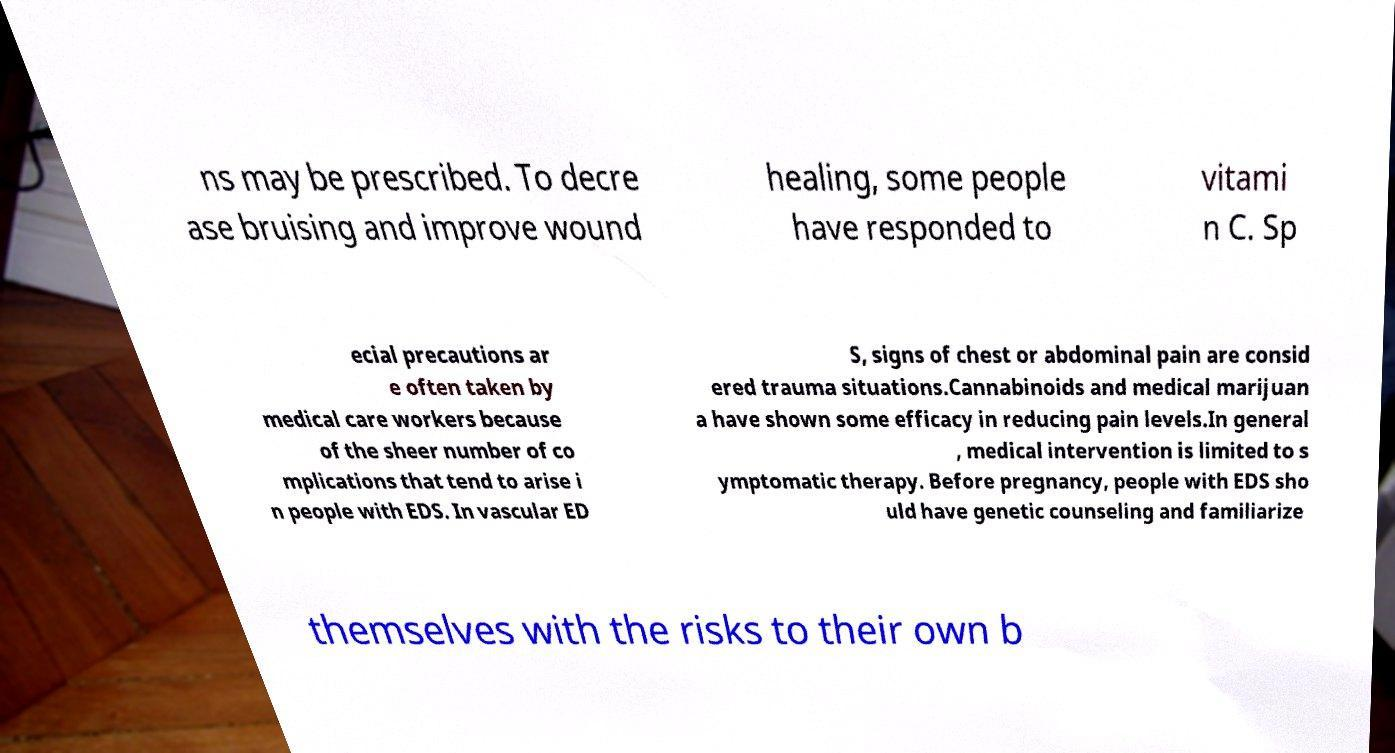I need the written content from this picture converted into text. Can you do that? ns may be prescribed. To decre ase bruising and improve wound healing, some people have responded to vitami n C. Sp ecial precautions ar e often taken by medical care workers because of the sheer number of co mplications that tend to arise i n people with EDS. In vascular ED S, signs of chest or abdominal pain are consid ered trauma situations.Cannabinoids and medical marijuan a have shown some efficacy in reducing pain levels.In general , medical intervention is limited to s ymptomatic therapy. Before pregnancy, people with EDS sho uld have genetic counseling and familiarize themselves with the risks to their own b 